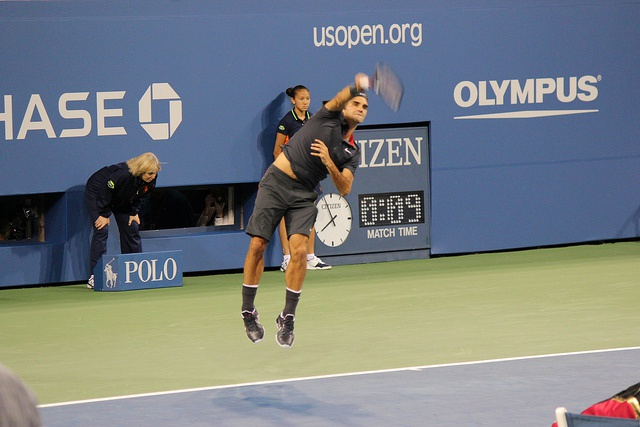Describe the objects in this image and their specific colors. I can see people in gray, black, tan, and brown tones, people in gray, black, tan, and navy tones, people in gray, black, tan, and red tones, clock in gray, lightgray, and darkgray tones, and tennis racket in gray tones in this image. 